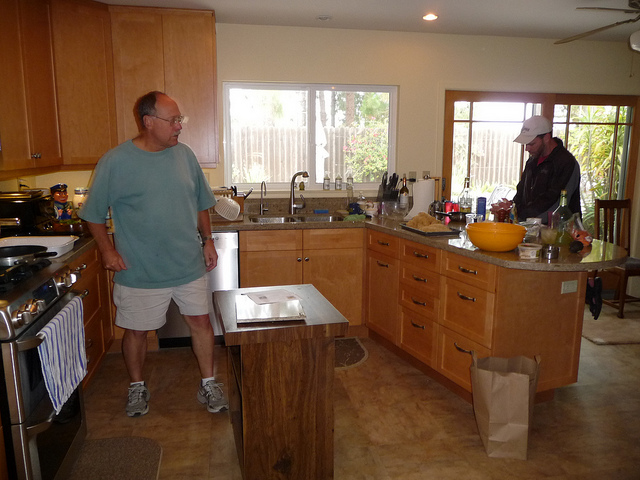<image>Are the windows facing the front yard? It is unknown whether the windows are facing the front yard. Are the windows facing the front yard? I don't know if the windows are facing the front yard. It seems that they are not facing the front yard. 